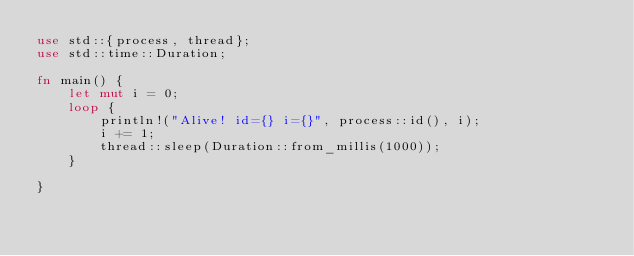Convert code to text. <code><loc_0><loc_0><loc_500><loc_500><_Rust_>use std::{process, thread};
use std::time::Duration;

fn main() {
    let mut i = 0;
    loop {
        println!("Alive! id={} i={}", process::id(), i);
        i += 1;
        thread::sleep(Duration::from_millis(1000));
    }

}
</code> 